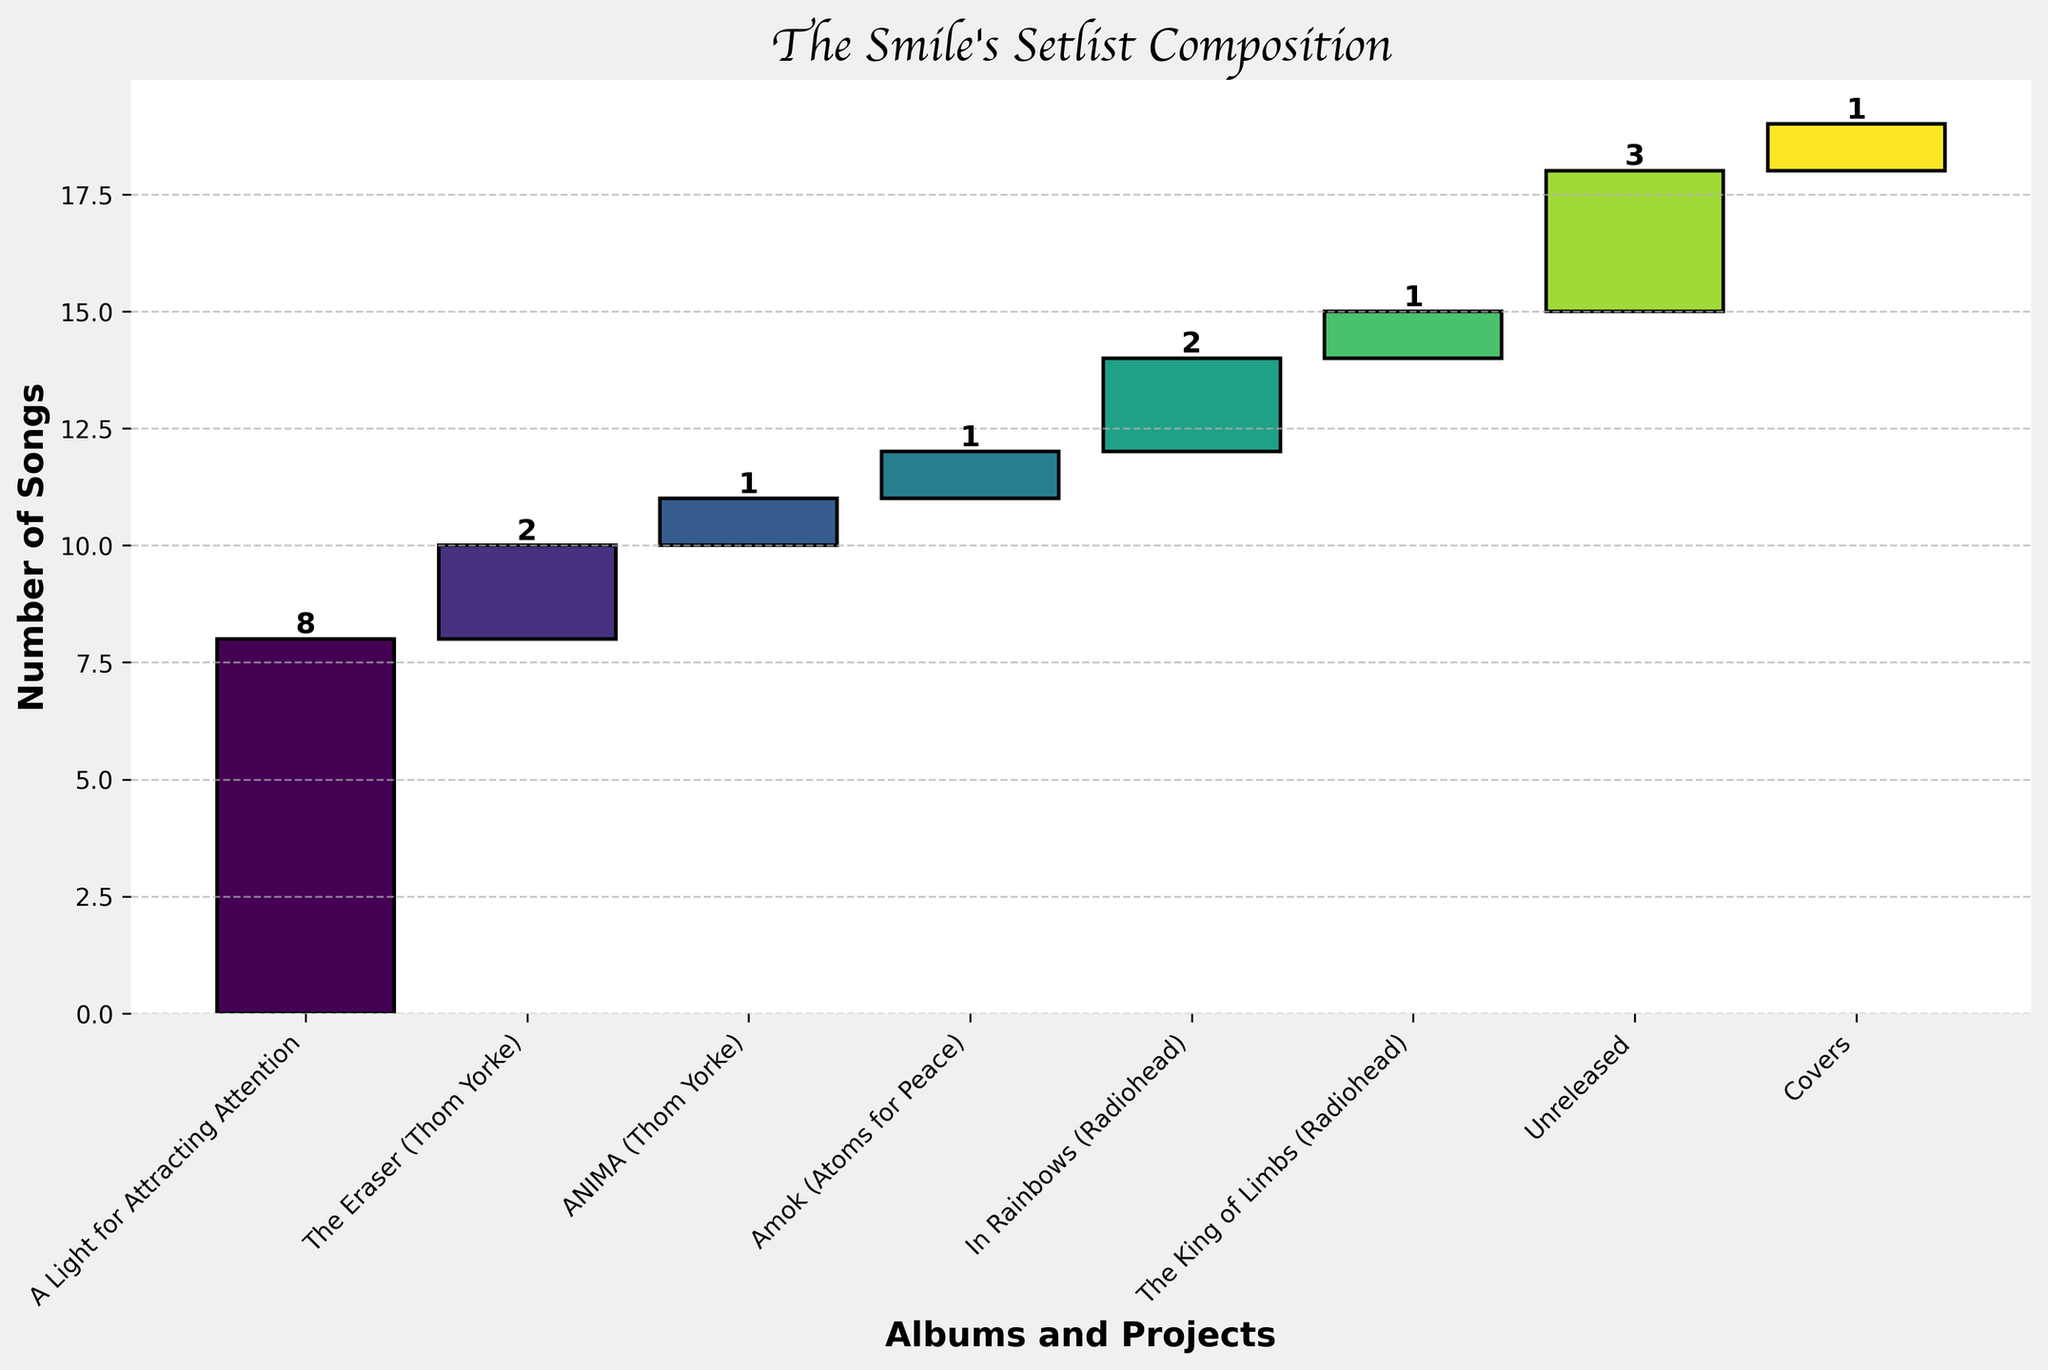How many categories of songs are shown in the chart? Count the number of distinct categories shown on the x-axis.
Answer: 8 Which album contributes the most songs to the setlist? Identify the category with the highest value bar in the chart.
Answer: A Light for Attracting Attention What is the total number of songs in The Smile's setlist? Sum the values of all the bars in the chart: 8 + 2 + 1 + 1 + 2 + 1 + 3 + 1.
Answer: 19 How many songs come from Thom Yorke's solo projects? Sum the values for "The Eraser" and "ANIMA": 2 + 1.
Answer: 3 Which category has a value equal to the number of songs from "The Eraser" and "Amok" combined? Calculate the combined value for "The Eraser" and "Amok" (2 + 1) and identify the category with the same value.
Answer: Unreleased How many more songs are from the album "A Light for Attracting Attention" than from Radiohead's album "In Rainbows"? Subtract the number of songs from "In Rainbows" (2) from the number of songs in "A Light for Attracting Attention" (8): 8 - 2.
Answer: 6 Which categories have only one song each? Identify bars with a value of 1. These are "ANIMA", "Amok", "The King of Limbs", and "Covers".
Answer: ANIMA, Amok, The King of Limbs, Covers How many Radiohead albums are included in the setlist? Identify the categories that correspond to Radiohead albums ("In Rainbows" and "The King of Limbs").
Answer: 2 What is the cumulative total of songs up to and including "Unreleased"? Add the values cumulatively up to "Unreleased": 8 (A Light for Attracting Attention) + 2 (The Eraser) + 1 (ANIMA) + 1 (Amok) + 2 (In Rainbows) + 1 (The King of Limbs) + 3 (Unreleased).
Answer: 18 Which category comes directly after "A Light for Attracting Attention" on the x-axis? Identify the category positioned immediately to the right of "A Light for Attracting Attention".
Answer: The Eraser 